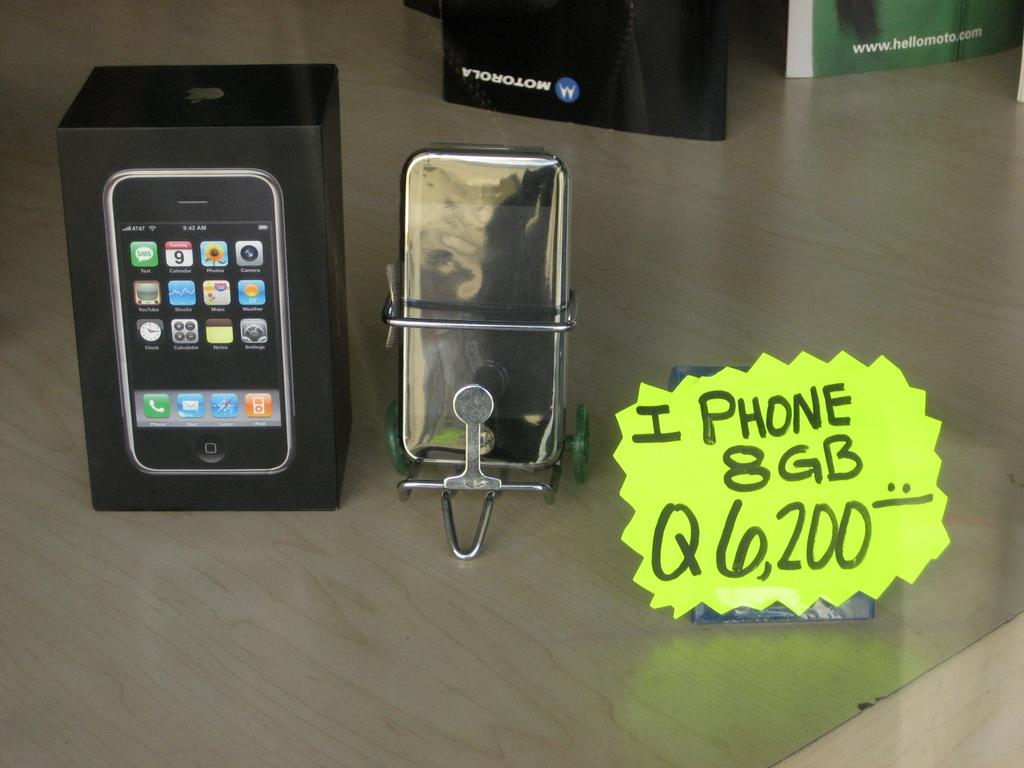<image>
Share a concise interpretation of the image provided. The yellow sign is advertising an I PHONE with 8GB. 